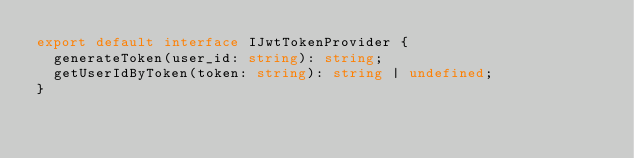<code> <loc_0><loc_0><loc_500><loc_500><_TypeScript_>export default interface IJwtTokenProvider {
  generateToken(user_id: string): string;
  getUserIdByToken(token: string): string | undefined;
}
</code> 